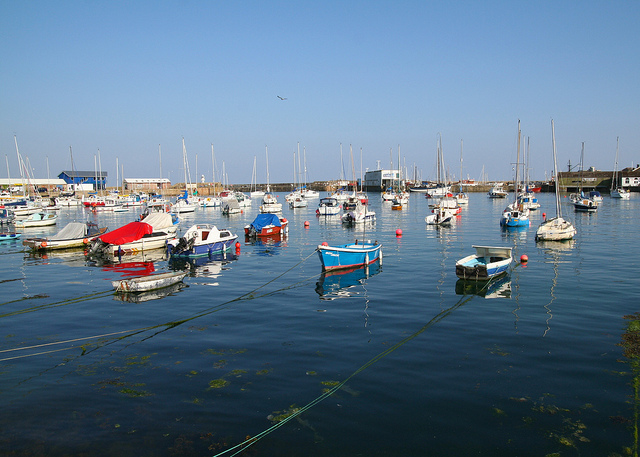What activities might people engage in at this harbor? People at this harbor might enjoy sailing, fishing, or simply strolling along the docks to admire the boats and the view, possibly stopping at nearby cafes or shops. Are there any signs of wildlife or nature in this scene? Yes, there are elements of wildlife and nature visible. For instance, there's a bird flying above the harbor, and there seem to be some aquatic plants in the water, adding to the ecosystem's diversity. 